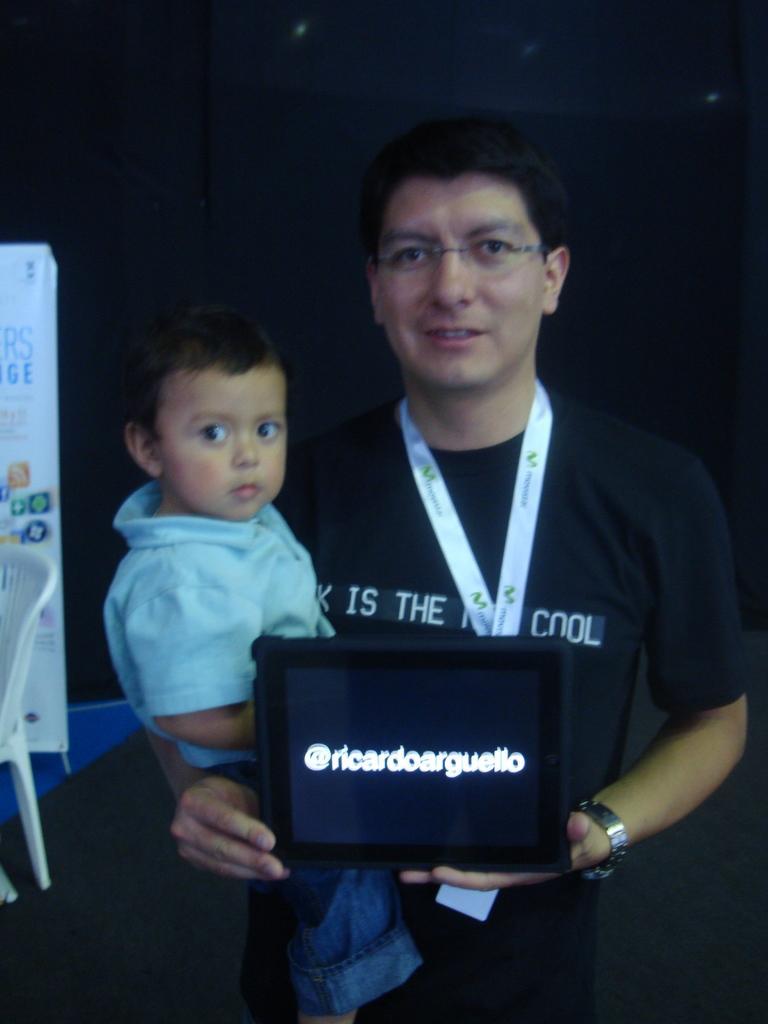Can you describe this image briefly? In this picture we can see a man and a kid, he is holding an object, beside to him we can find a chair and a hoarding. 